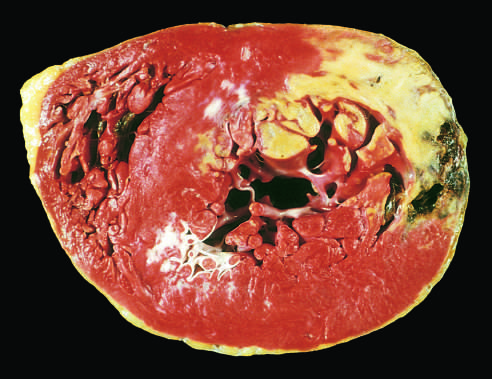what is the absence of staining due to?
Answer the question using a single word or phrase. Enzyme leakage after cell death 